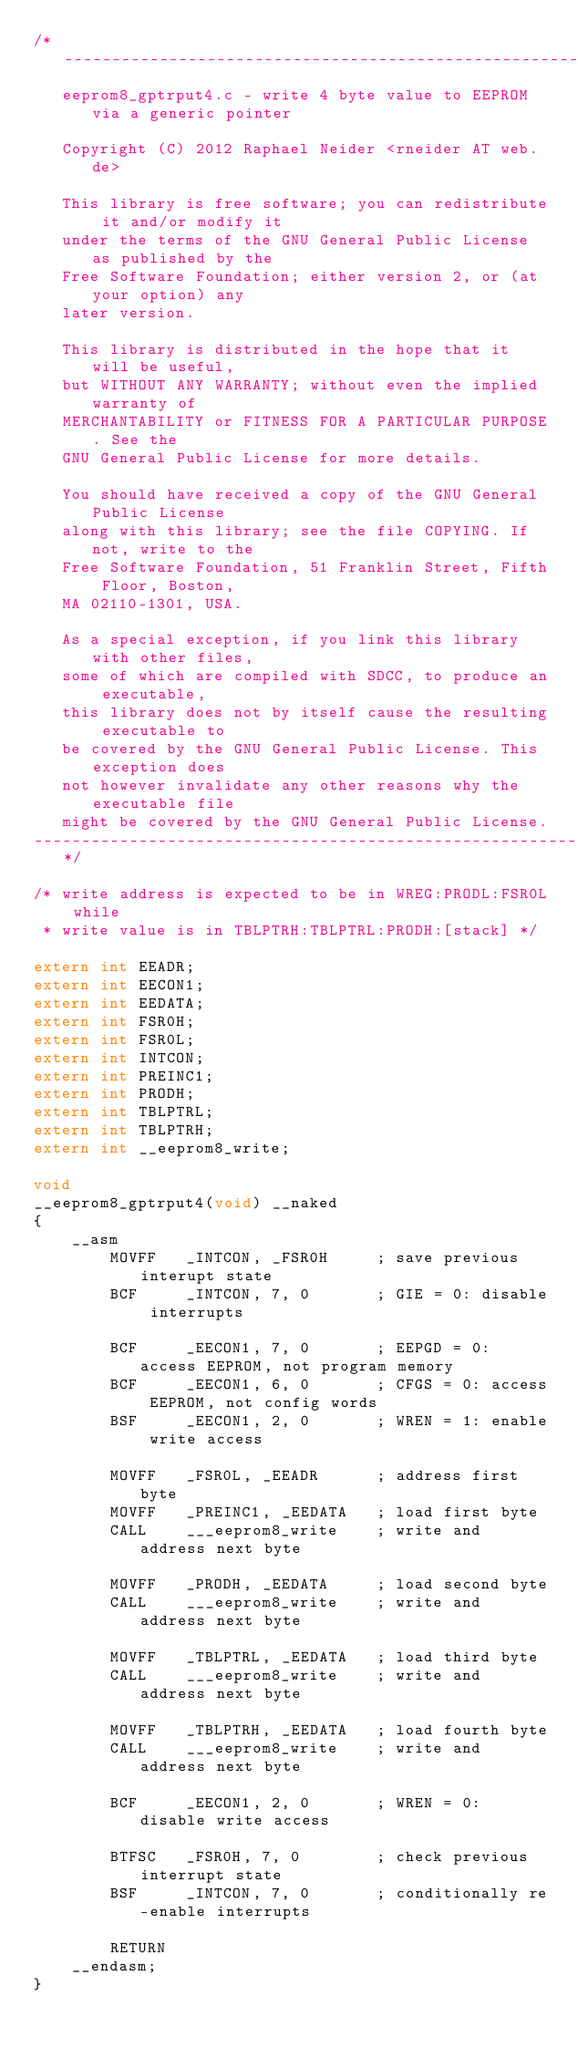Convert code to text. <code><loc_0><loc_0><loc_500><loc_500><_C_>/*-------------------------------------------------------------------------
   eeprom8_gptrput4.c - write 4 byte value to EEPROM via a generic pointer

   Copyright (C) 2012 Raphael Neider <rneider AT web.de>

   This library is free software; you can redistribute it and/or modify it
   under the terms of the GNU General Public License as published by the
   Free Software Foundation; either version 2, or (at your option) any
   later version.

   This library is distributed in the hope that it will be useful,
   but WITHOUT ANY WARRANTY; without even the implied warranty of
   MERCHANTABILITY or FITNESS FOR A PARTICULAR PURPOSE. See the
   GNU General Public License for more details.

   You should have received a copy of the GNU General Public License 
   along with this library; see the file COPYING. If not, write to the
   Free Software Foundation, 51 Franklin Street, Fifth Floor, Boston,
   MA 02110-1301, USA.

   As a special exception, if you link this library with other files,
   some of which are compiled with SDCC, to produce an executable,
   this library does not by itself cause the resulting executable to
   be covered by the GNU General Public License. This exception does
   not however invalidate any other reasons why the executable file
   might be covered by the GNU General Public License.
-------------------------------------------------------------------------*/

/* write address is expected to be in WREG:PRODL:FSR0L while
 * write value is in TBLPTRH:TBLPTRL:PRODH:[stack] */

extern int EEADR;
extern int EECON1;
extern int EEDATA;
extern int FSR0H;
extern int FSR0L;
extern int INTCON;
extern int PREINC1;
extern int PRODH;
extern int TBLPTRL;
extern int TBLPTRH;
extern int __eeprom8_write;

void
__eeprom8_gptrput4(void) __naked
{
    __asm
        MOVFF   _INTCON, _FSR0H     ; save previous interupt state
        BCF     _INTCON, 7, 0       ; GIE = 0: disable interrupts

        BCF     _EECON1, 7, 0       ; EEPGD = 0: access EEPROM, not program memory
        BCF     _EECON1, 6, 0       ; CFGS = 0: access EEPROM, not config words
        BSF     _EECON1, 2, 0       ; WREN = 1: enable write access

        MOVFF   _FSR0L, _EEADR      ; address first byte
        MOVFF   _PREINC1, _EEDATA   ; load first byte
        CALL    ___eeprom8_write    ; write and address next byte

        MOVFF   _PRODH, _EEDATA     ; load second byte
        CALL    ___eeprom8_write    ; write and address next byte

        MOVFF   _TBLPTRL, _EEDATA   ; load third byte
        CALL    ___eeprom8_write    ; write and address next byte

        MOVFF   _TBLPTRH, _EEDATA   ; load fourth byte
        CALL    ___eeprom8_write    ; write and address next byte

        BCF     _EECON1, 2, 0       ; WREN = 0: disable write access

        BTFSC   _FSR0H, 7, 0        ; check previous interrupt state
        BSF     _INTCON, 7, 0       ; conditionally re-enable interrupts

        RETURN
    __endasm;
}
</code> 